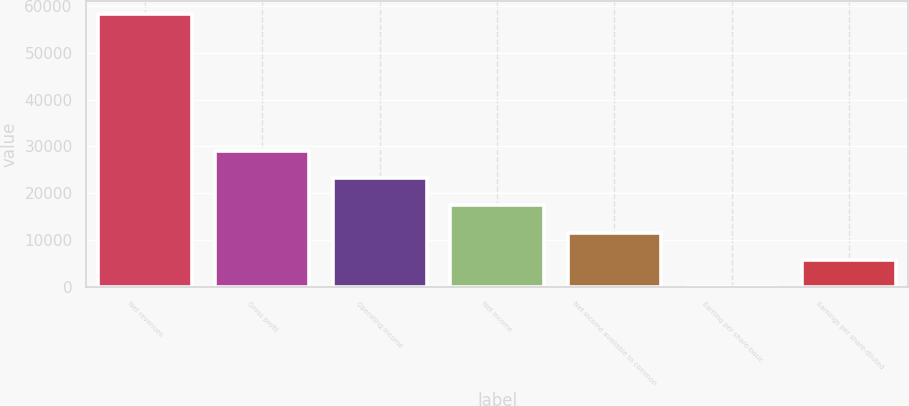<chart> <loc_0><loc_0><loc_500><loc_500><bar_chart><fcel>Net revenues<fcel>Gross profit<fcel>Operating income<fcel>Net income<fcel>Net income available to common<fcel>Earning per share-basic<fcel>Earnings per share-diluted<nl><fcel>58187<fcel>29093.5<fcel>23274.8<fcel>17456.1<fcel>11637.4<fcel>0.05<fcel>5818.74<nl></chart> 